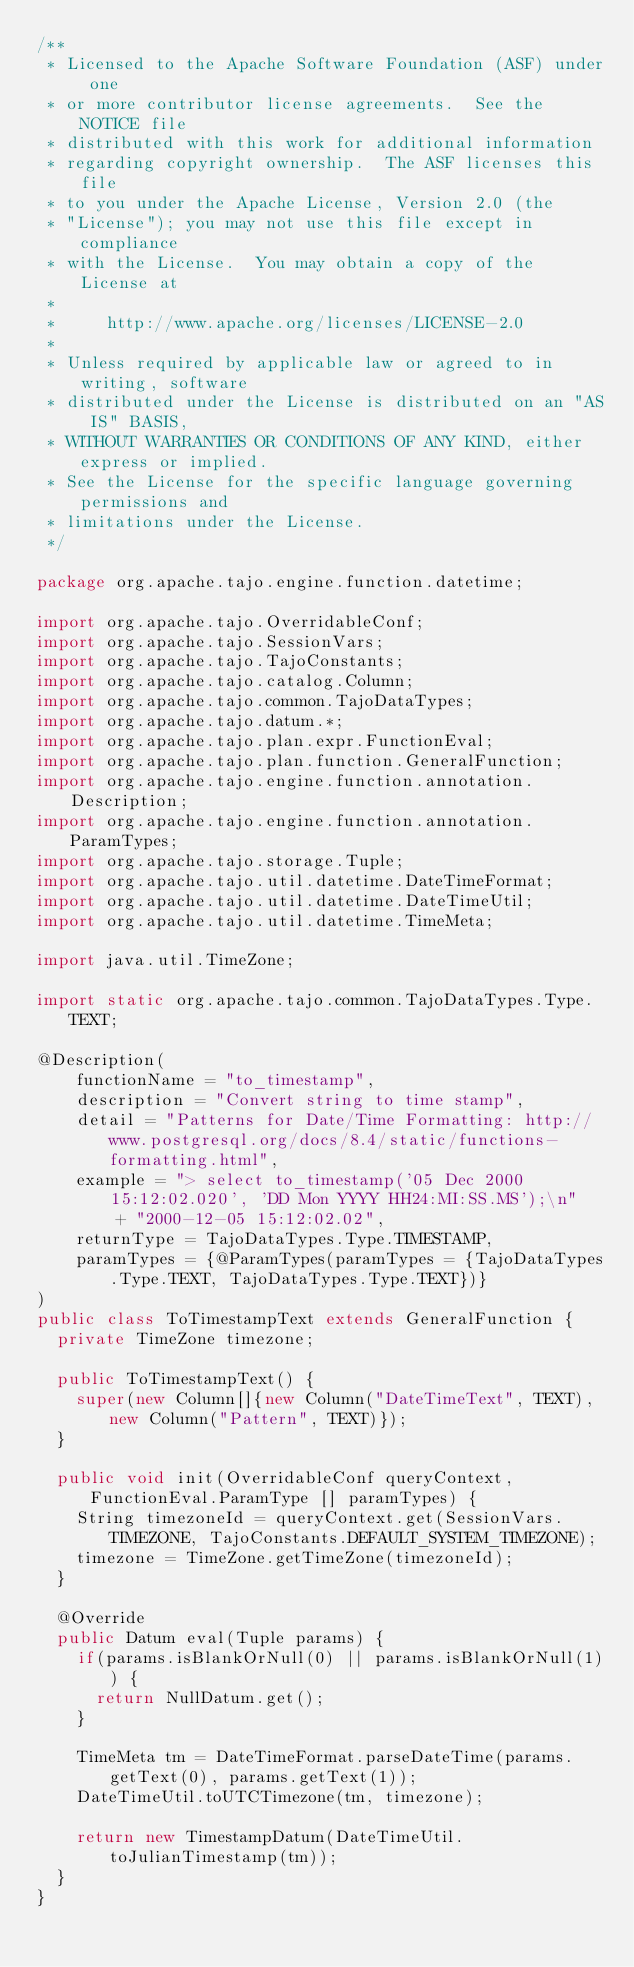<code> <loc_0><loc_0><loc_500><loc_500><_Java_>/**
 * Licensed to the Apache Software Foundation (ASF) under one
 * or more contributor license agreements.  See the NOTICE file
 * distributed with this work for additional information
 * regarding copyright ownership.  The ASF licenses this file
 * to you under the Apache License, Version 2.0 (the
 * "License"); you may not use this file except in compliance
 * with the License.  You may obtain a copy of the License at
 *
 *     http://www.apache.org/licenses/LICENSE-2.0
 *
 * Unless required by applicable law or agreed to in writing, software
 * distributed under the License is distributed on an "AS IS" BASIS,
 * WITHOUT WARRANTIES OR CONDITIONS OF ANY KIND, either express or implied.
 * See the License for the specific language governing permissions and
 * limitations under the License.
 */

package org.apache.tajo.engine.function.datetime;

import org.apache.tajo.OverridableConf;
import org.apache.tajo.SessionVars;
import org.apache.tajo.TajoConstants;
import org.apache.tajo.catalog.Column;
import org.apache.tajo.common.TajoDataTypes;
import org.apache.tajo.datum.*;
import org.apache.tajo.plan.expr.FunctionEval;
import org.apache.tajo.plan.function.GeneralFunction;
import org.apache.tajo.engine.function.annotation.Description;
import org.apache.tajo.engine.function.annotation.ParamTypes;
import org.apache.tajo.storage.Tuple;
import org.apache.tajo.util.datetime.DateTimeFormat;
import org.apache.tajo.util.datetime.DateTimeUtil;
import org.apache.tajo.util.datetime.TimeMeta;

import java.util.TimeZone;

import static org.apache.tajo.common.TajoDataTypes.Type.TEXT;

@Description(
    functionName = "to_timestamp",
    description = "Convert string to time stamp",
    detail = "Patterns for Date/Time Formatting: http://www.postgresql.org/docs/8.4/static/functions-formatting.html",
    example = "> select to_timestamp('05 Dec 2000 15:12:02.020', 'DD Mon YYYY HH24:MI:SS.MS');\n"
        + "2000-12-05 15:12:02.02",
    returnType = TajoDataTypes.Type.TIMESTAMP,
    paramTypes = {@ParamTypes(paramTypes = {TajoDataTypes.Type.TEXT, TajoDataTypes.Type.TEXT})}
)
public class ToTimestampText extends GeneralFunction {
  private TimeZone timezone;

  public ToTimestampText() {
    super(new Column[]{new Column("DateTimeText", TEXT), new Column("Pattern", TEXT)});
  }

  public void init(OverridableConf queryContext, FunctionEval.ParamType [] paramTypes) {
    String timezoneId = queryContext.get(SessionVars.TIMEZONE, TajoConstants.DEFAULT_SYSTEM_TIMEZONE);
    timezone = TimeZone.getTimeZone(timezoneId);
  }

  @Override
  public Datum eval(Tuple params) {
    if(params.isBlankOrNull(0) || params.isBlankOrNull(1)) {
      return NullDatum.get();
    }

    TimeMeta tm = DateTimeFormat.parseDateTime(params.getText(0), params.getText(1));
    DateTimeUtil.toUTCTimezone(tm, timezone);

    return new TimestampDatum(DateTimeUtil.toJulianTimestamp(tm));
  }
}
</code> 